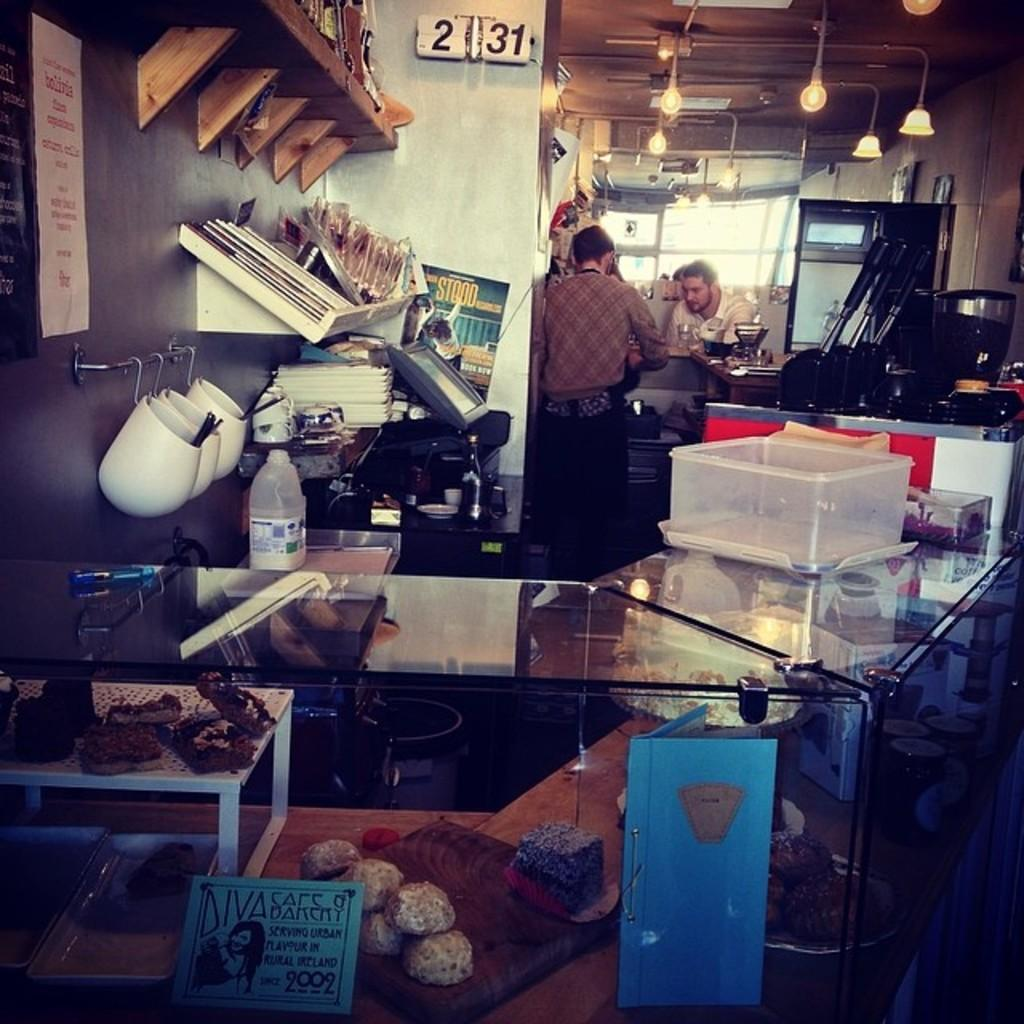What type of structure can be seen in the image? There is a wall in the image. What objects are present in the image that could be used for holding or serving food? There are bowls and a tray in the image. What type of container is visible in the image? There is a bottle in the image. What can be seen in the image that might be consumed as food? There are food items in the image. How many people are present in the image? There are two people in the image. Can you see any mice rolling around in the image? There are no mice or rolling activity present in the image. 